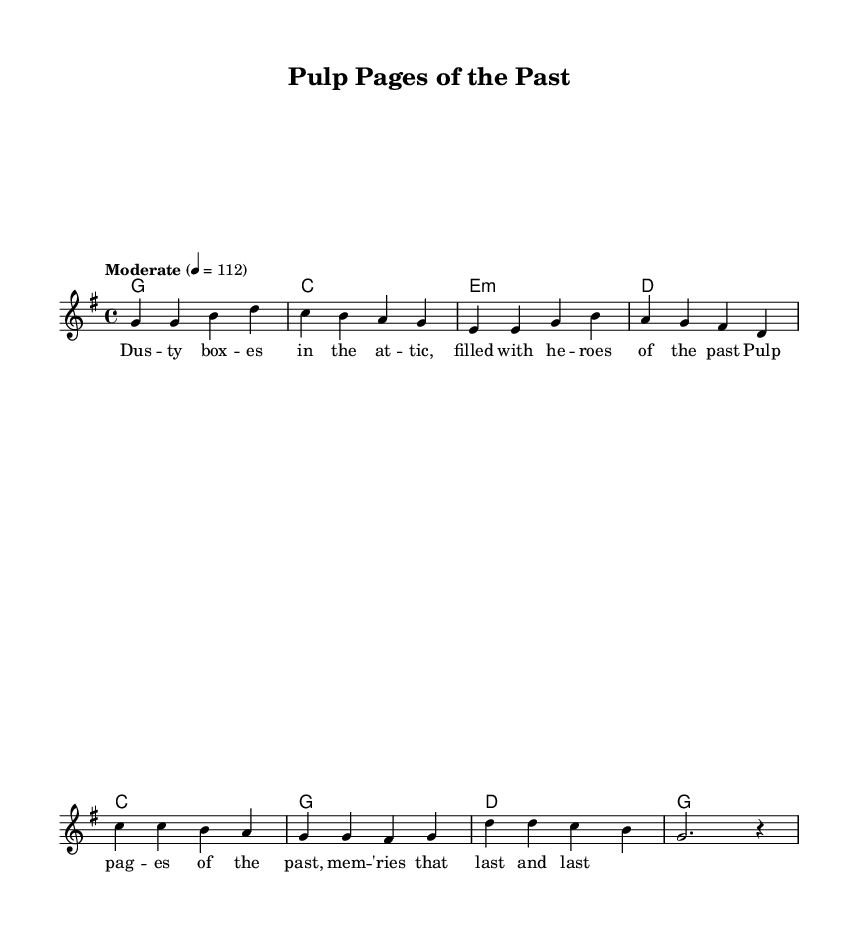What is the key signature of this music? The key signature is determined by the number of sharps or flats at the beginning of the staff. In this case, there are no accidentals, indicating the key is G major, which contains one sharp (F#).
Answer: G major What is the time signature of this music? The time signature is found at the beginning of the staff and is represented as a fraction. Here, it shows '4/4', meaning there are four beats per measure with a quarter note getting one beat.
Answer: 4/4 What is the tempo marking in this music? The tempo is indicated at the beginning of the score as a speed indication. It states "Moderate" followed by a number (112), suggesting how many quarter note beats occur in a minute.
Answer: Moderate 112 What chords are used in the verse? The verse chords are indicated in the chord section, aligning with the melody. The chords are G, C, E minor, and D, which are shown in sequence.
Answer: G, C, E minor, D How many measures are in the chorus? By counting the bar lines in the chorus section, we find that there are four distinct sets of notes or phrases, indicating it spans four measures.
Answer: 4 What do the lyrics of the chorus highlight? The lyrics are depicted below the melody and emphasize nostalgia for the past with references to "Pulp pages" and "memories". They celebrate treasured memories related to comic book collecting.
Answer: Nostalgia Which genre is this music primarily associated with? This music is characterized by a blend of elements typical in country and rock styles—highlighted in the lyrics and structure—indicating it belongs to the Country Rock genre.
Answer: Country Rock 